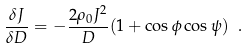Convert formula to latex. <formula><loc_0><loc_0><loc_500><loc_500>\frac { \delta J } { \delta D } = - \frac { 2 \rho _ { 0 } J ^ { 2 } } { D } ( 1 + \cos \phi \cos \psi ) \ .</formula> 